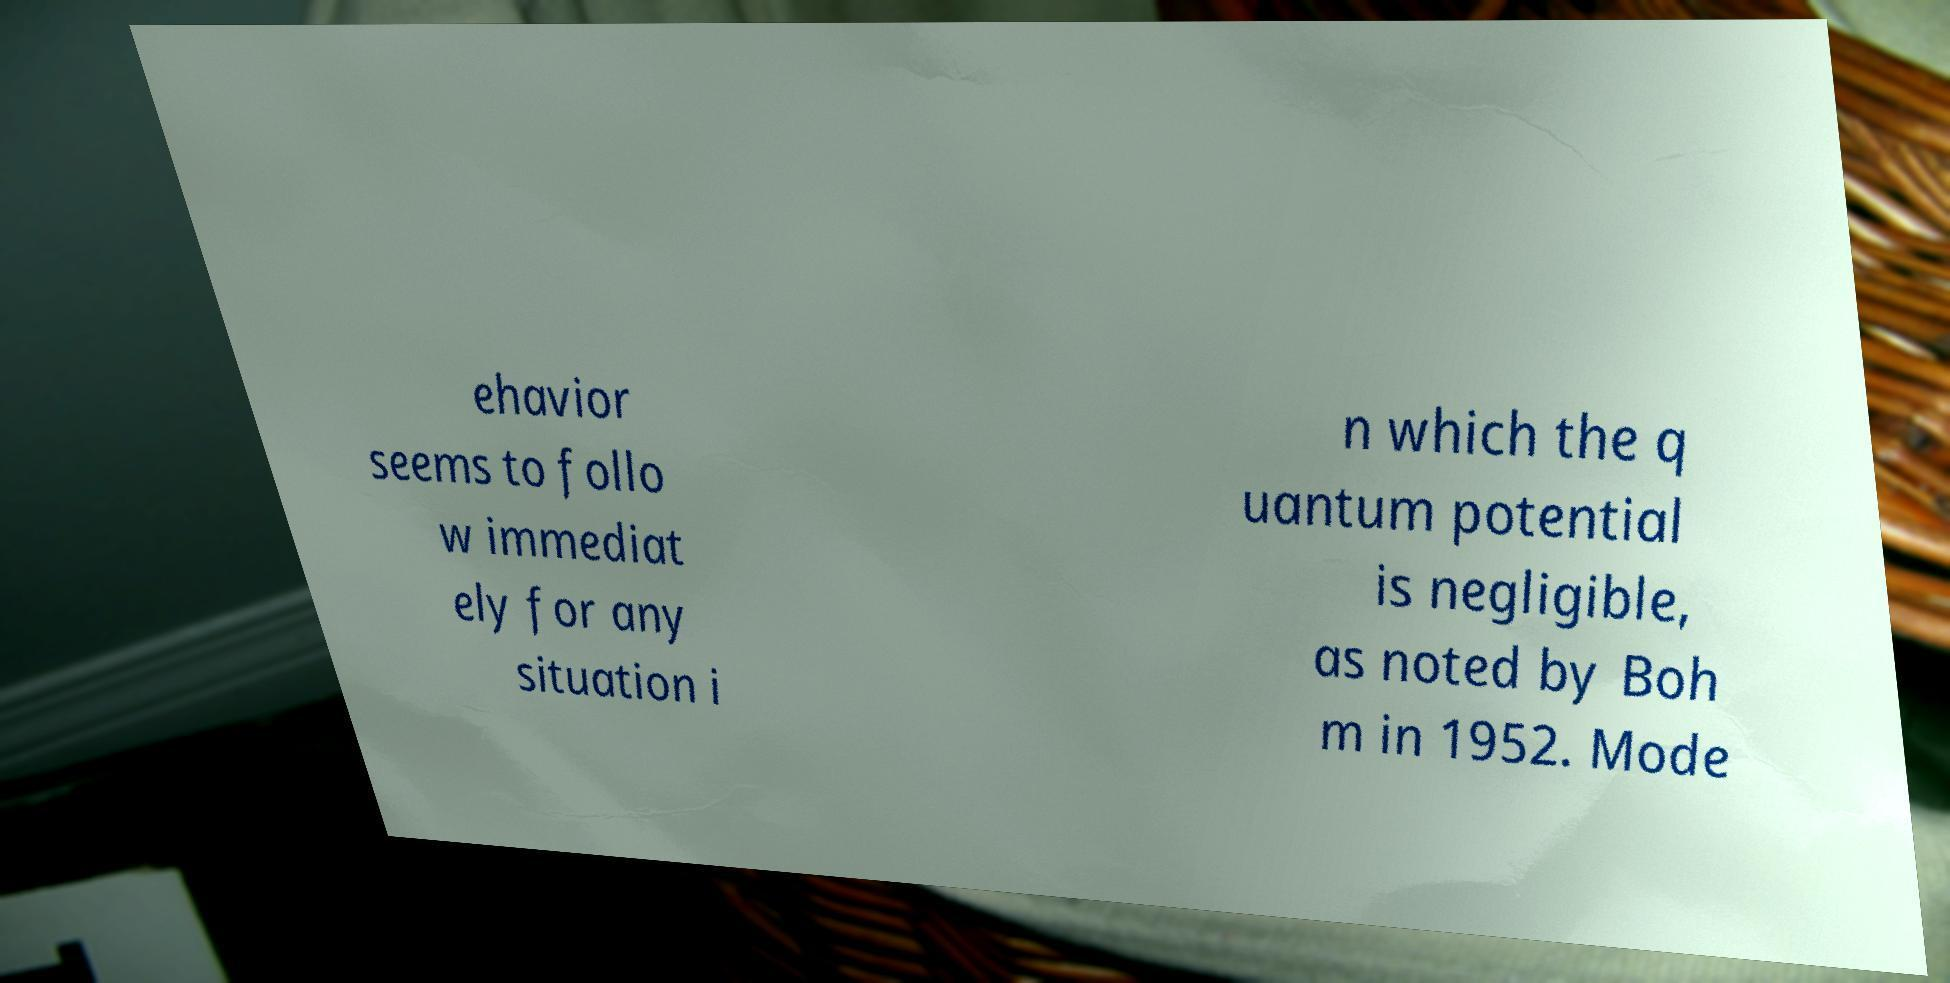What messages or text are displayed in this image? I need them in a readable, typed format. ehavior seems to follo w immediat ely for any situation i n which the q uantum potential is negligible, as noted by Boh m in 1952. Mode 